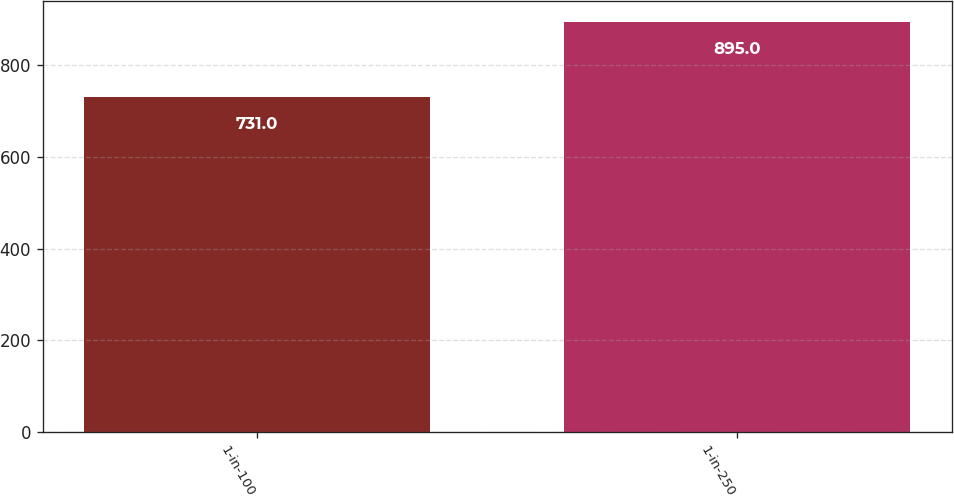Convert chart to OTSL. <chart><loc_0><loc_0><loc_500><loc_500><bar_chart><fcel>1-in-100<fcel>1-in-250<nl><fcel>731<fcel>895<nl></chart> 